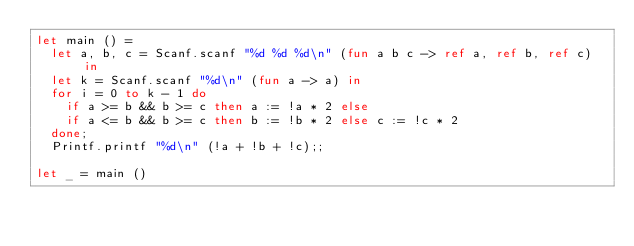<code> <loc_0><loc_0><loc_500><loc_500><_OCaml_>let main () =
  let a, b, c = Scanf.scanf "%d %d %d\n" (fun a b c -> ref a, ref b, ref c) in
  let k = Scanf.scanf "%d\n" (fun a -> a) in
  for i = 0 to k - 1 do
    if a >= b && b >= c then a := !a * 2 else
    if a <= b && b >= c then b := !b * 2 else c := !c * 2
  done;
  Printf.printf "%d\n" (!a + !b + !c);;

let _ = main ()
</code> 